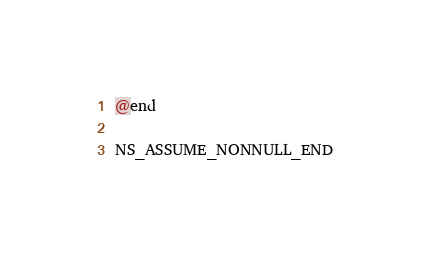Convert code to text. <code><loc_0><loc_0><loc_500><loc_500><_C_>@end

NS_ASSUME_NONNULL_END
</code> 